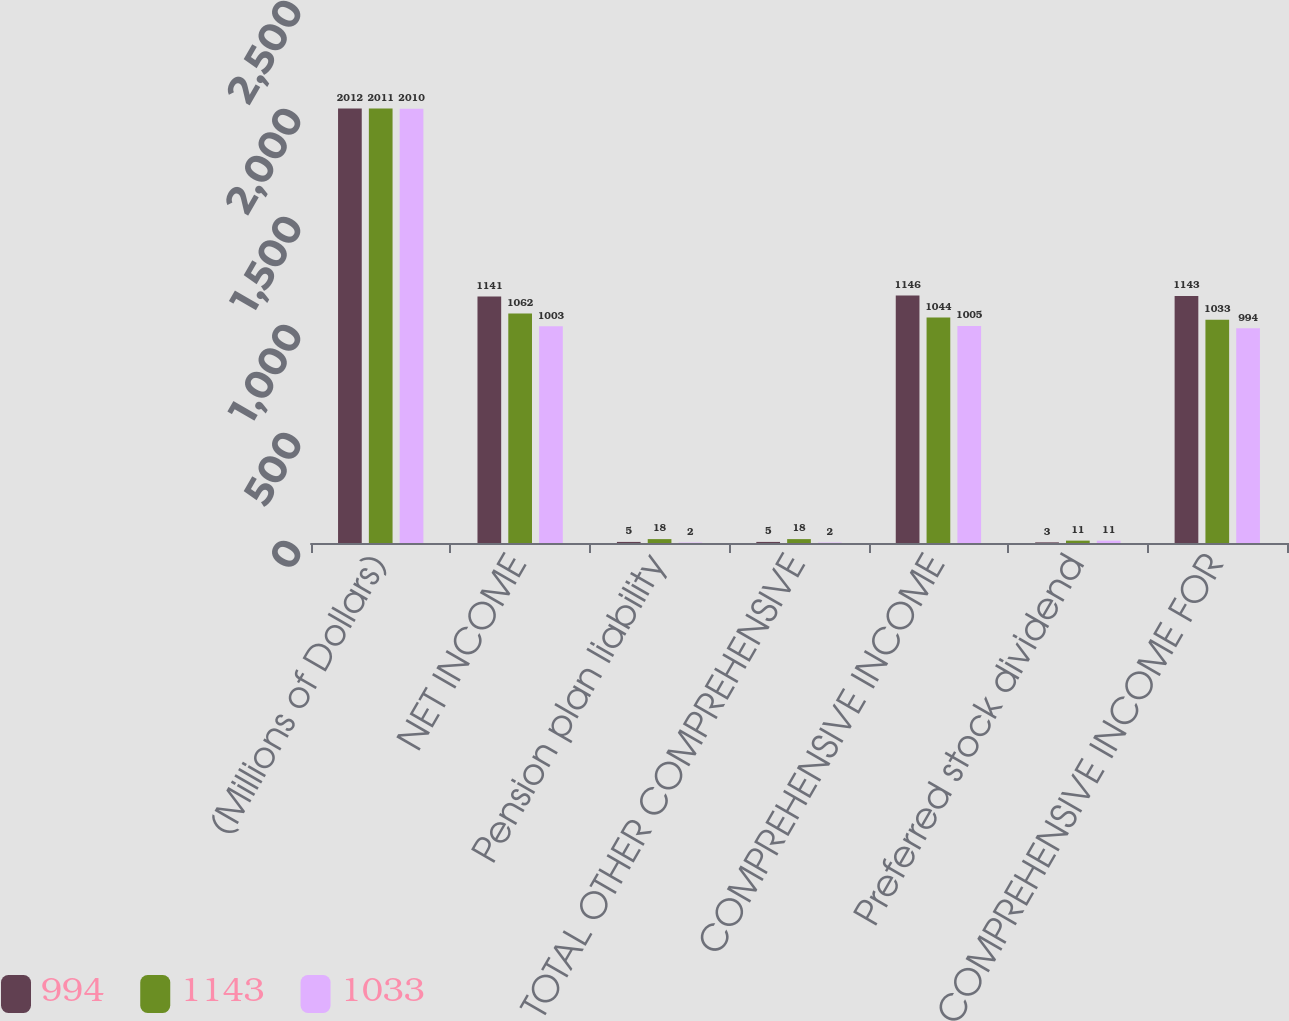<chart> <loc_0><loc_0><loc_500><loc_500><stacked_bar_chart><ecel><fcel>(Millions of Dollars)<fcel>NET INCOME<fcel>Pension plan liability<fcel>TOTAL OTHER COMPREHENSIVE<fcel>COMPREHENSIVE INCOME<fcel>Preferred stock dividend<fcel>COMPREHENSIVE INCOME FOR<nl><fcel>994<fcel>2012<fcel>1141<fcel>5<fcel>5<fcel>1146<fcel>3<fcel>1143<nl><fcel>1143<fcel>2011<fcel>1062<fcel>18<fcel>18<fcel>1044<fcel>11<fcel>1033<nl><fcel>1033<fcel>2010<fcel>1003<fcel>2<fcel>2<fcel>1005<fcel>11<fcel>994<nl></chart> 